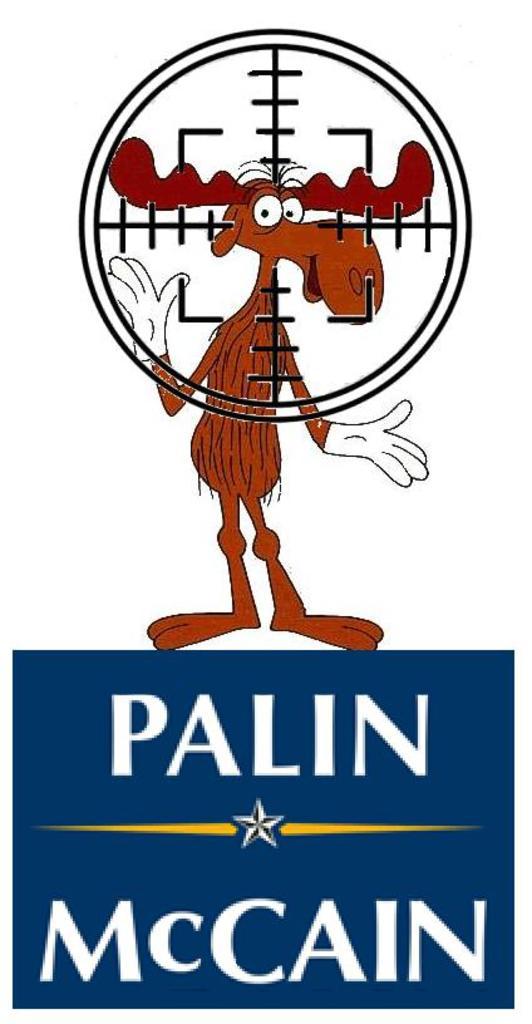Who is running in this ad?
Give a very brief answer. Palin mccain. What are the last names of the two people displayed here?
Offer a very short reply. Palin, mccain. 